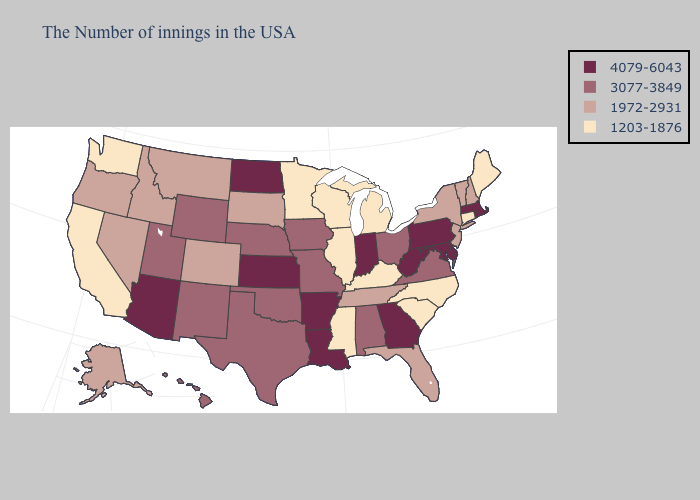How many symbols are there in the legend?
Be succinct. 4. Name the states that have a value in the range 1203-1876?
Short answer required. Maine, Connecticut, North Carolina, South Carolina, Michigan, Kentucky, Wisconsin, Illinois, Mississippi, Minnesota, California, Washington. Does North Carolina have the highest value in the USA?
Short answer required. No. Does Alabama have a higher value than Arkansas?
Short answer required. No. Name the states that have a value in the range 1972-2931?
Answer briefly. New Hampshire, Vermont, New York, New Jersey, Florida, Tennessee, South Dakota, Colorado, Montana, Idaho, Nevada, Oregon, Alaska. What is the value of Virginia?
Concise answer only. 3077-3849. What is the value of Illinois?
Give a very brief answer. 1203-1876. Does Arizona have the lowest value in the USA?
Quick response, please. No. Among the states that border New Hampshire , does Maine have the lowest value?
Be succinct. Yes. Among the states that border Nevada , does Oregon have the lowest value?
Write a very short answer. No. Name the states that have a value in the range 1203-1876?
Keep it brief. Maine, Connecticut, North Carolina, South Carolina, Michigan, Kentucky, Wisconsin, Illinois, Mississippi, Minnesota, California, Washington. Name the states that have a value in the range 1972-2931?
Answer briefly. New Hampshire, Vermont, New York, New Jersey, Florida, Tennessee, South Dakota, Colorado, Montana, Idaho, Nevada, Oregon, Alaska. Does Oklahoma have the lowest value in the USA?
Give a very brief answer. No. Name the states that have a value in the range 3077-3849?
Answer briefly. Virginia, Ohio, Alabama, Missouri, Iowa, Nebraska, Oklahoma, Texas, Wyoming, New Mexico, Utah, Hawaii. Does California have the lowest value in the USA?
Concise answer only. Yes. 